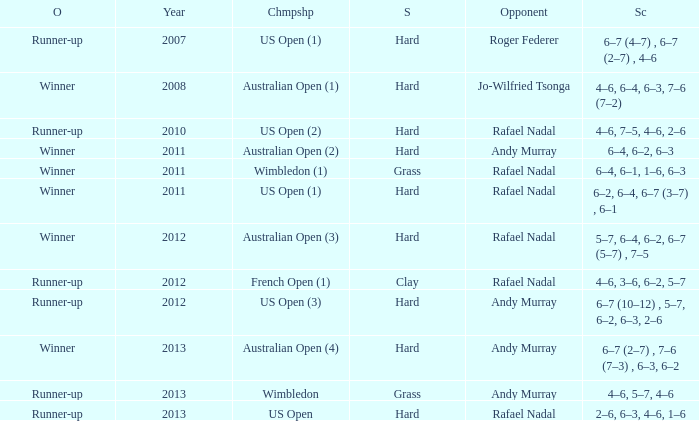What is the outcome of the 4–6, 6–4, 6–3, 7–6 (7–2) score? Winner. 